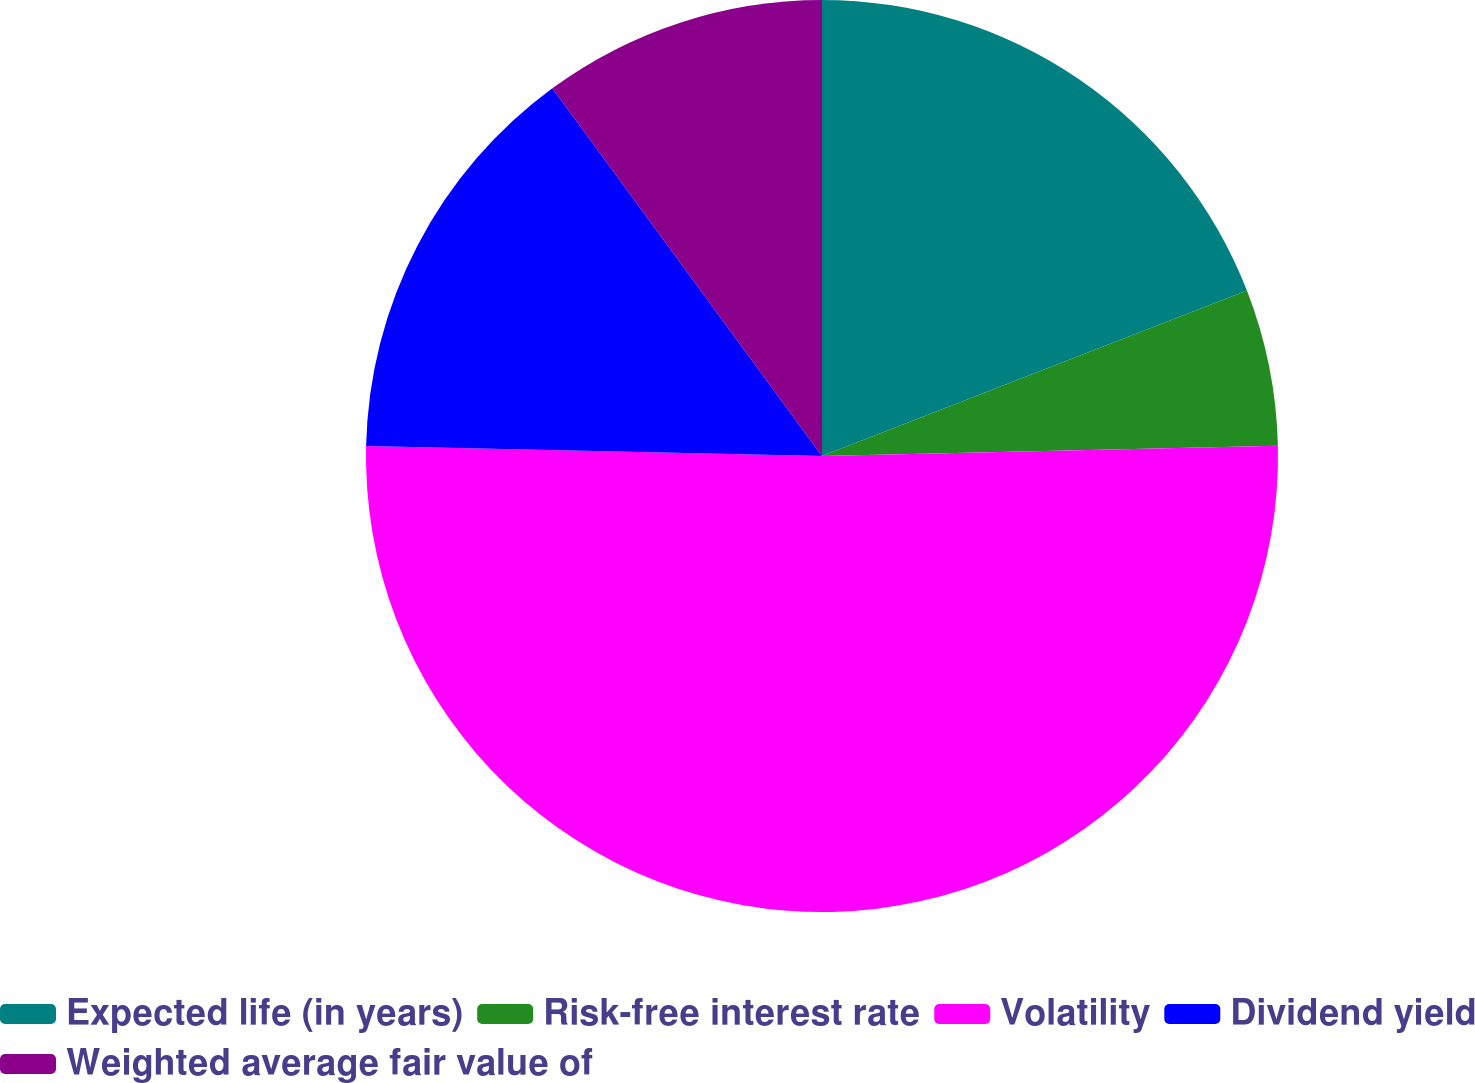Convert chart. <chart><loc_0><loc_0><loc_500><loc_500><pie_chart><fcel>Expected life (in years)<fcel>Risk-free interest rate<fcel>Volatility<fcel>Dividend yield<fcel>Weighted average fair value of<nl><fcel>19.09%<fcel>5.55%<fcel>50.71%<fcel>14.58%<fcel>10.07%<nl></chart> 